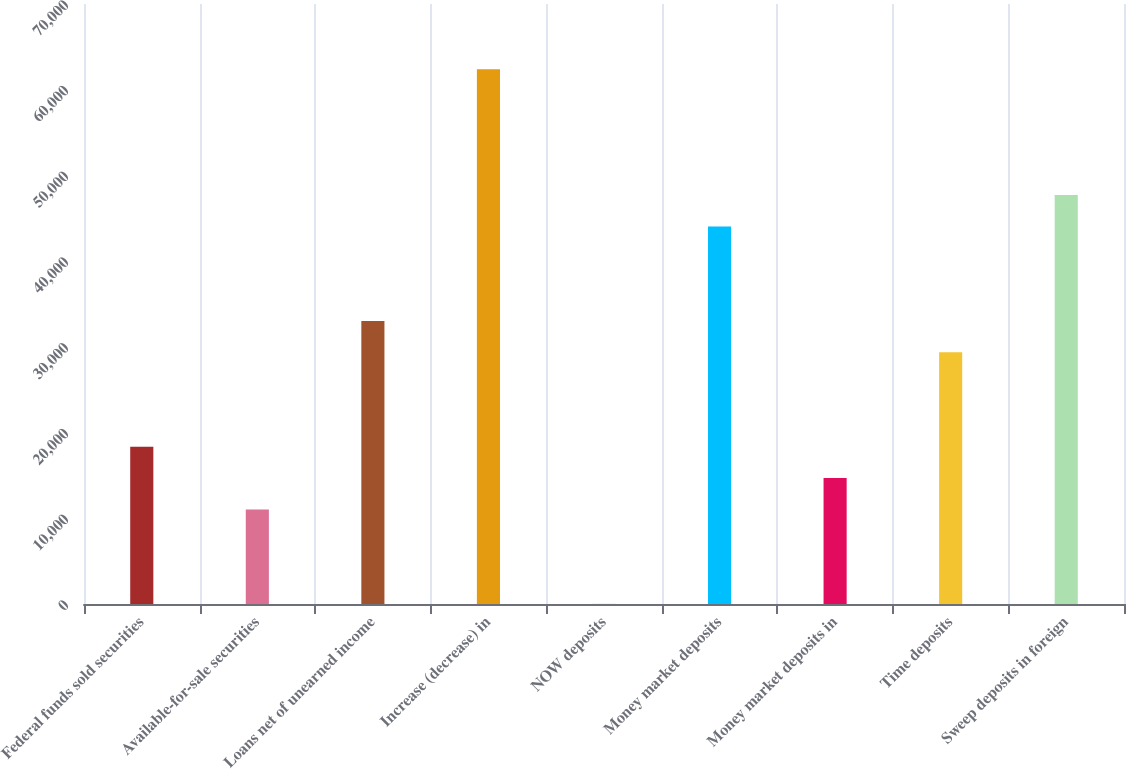Convert chart to OTSL. <chart><loc_0><loc_0><loc_500><loc_500><bar_chart><fcel>Federal funds sold securities<fcel>Available-for-sale securities<fcel>Loans net of unearned income<fcel>Increase (decrease) in<fcel>NOW deposits<fcel>Money market deposits<fcel>Money market deposits in<fcel>Time deposits<fcel>Sweep deposits in foreign<nl><fcel>18355<fcel>11017.4<fcel>33030.2<fcel>62380.6<fcel>11<fcel>44036.6<fcel>14686.2<fcel>29361.4<fcel>47705.4<nl></chart> 